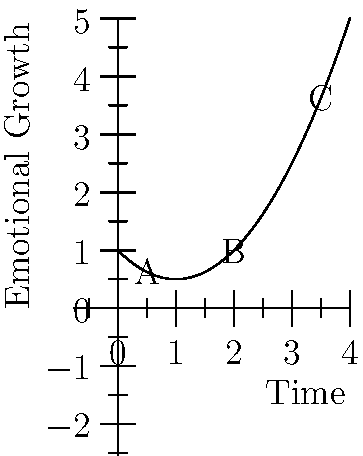Analyze the line graph representing a character's emotional growth over time. Which point on the curve indicates the most significant turning point in the character's development, and why? To determine the most significant turning point in the character's emotional growth, we need to analyze the graph's shape and the rate of change at different points:

1. Point A (early in the timeline): The curve is descending, indicating a initial decline in emotional growth.

2. Point B (middle of the timeline): This is where the curve changes from descending to ascending. It represents the lowest point of emotional growth and the beginning of positive development.

3. Point C (later in the timeline): The curve is ascending steeply, showing rapid emotional growth.

The most significant turning point is Point B because:
a) It marks the transition from negative to positive emotional growth.
b) It represents the character's lowest point, often a catalyst for change in character development.
c) After this point, the rate of emotional growth increases dramatically, indicating a fundamental shift in the character's arc.

This turning point likely represents a crucial moment in the story where the character faces a significant challenge or realization, leading to personal growth and development.
Answer: Point B 